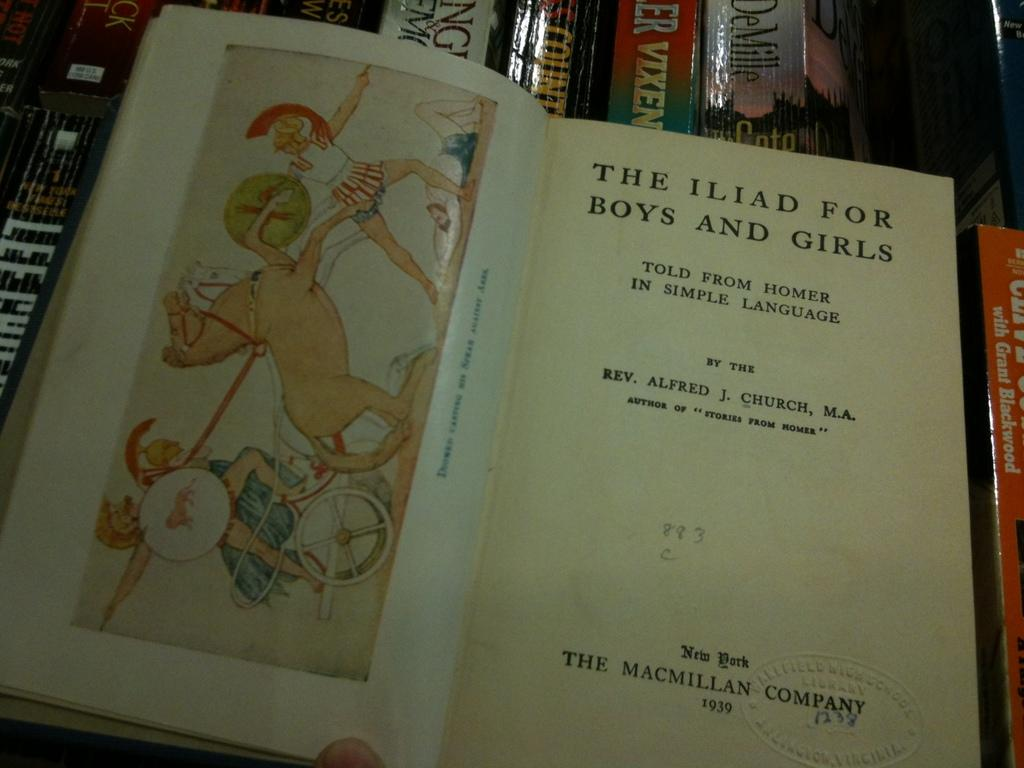<image>
Present a compact description of the photo's key features. Children's Iliad book for Boys and Girls published by the Macmillan Company of 1939. 